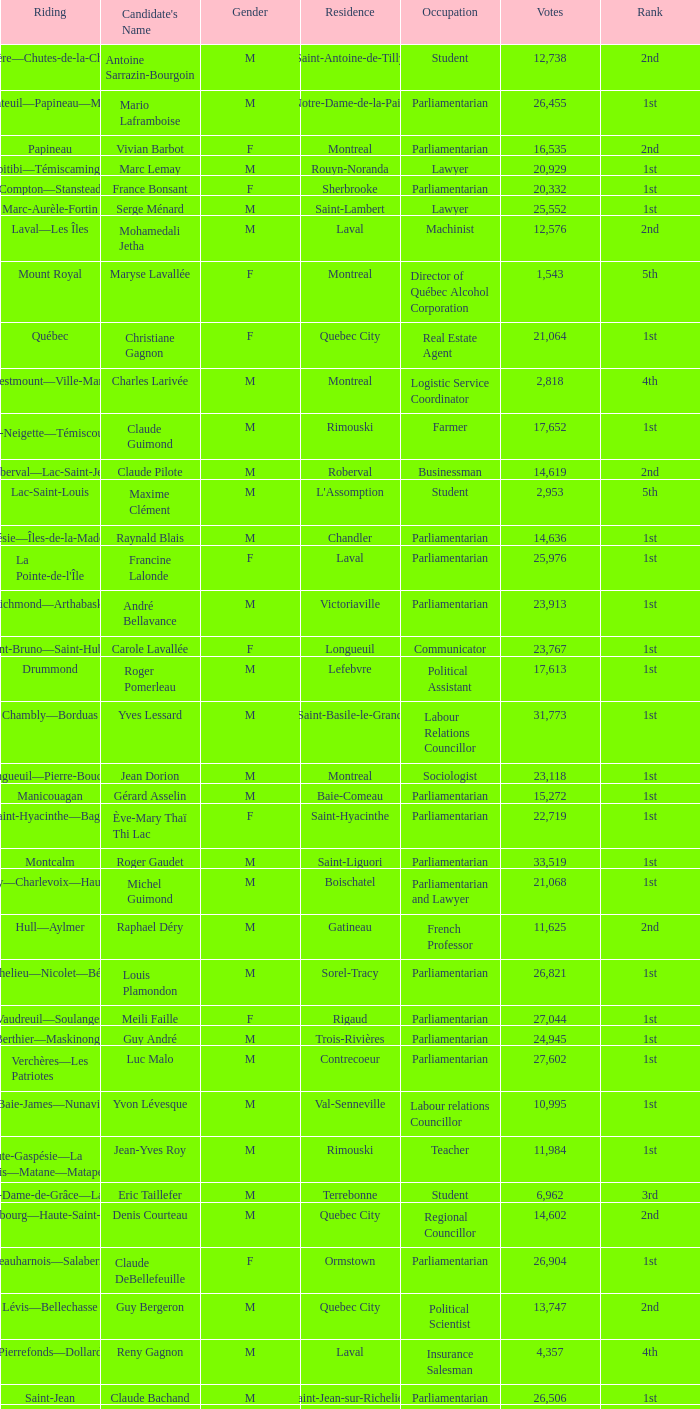What is the highest number of votes for the French Professor? 11625.0. 